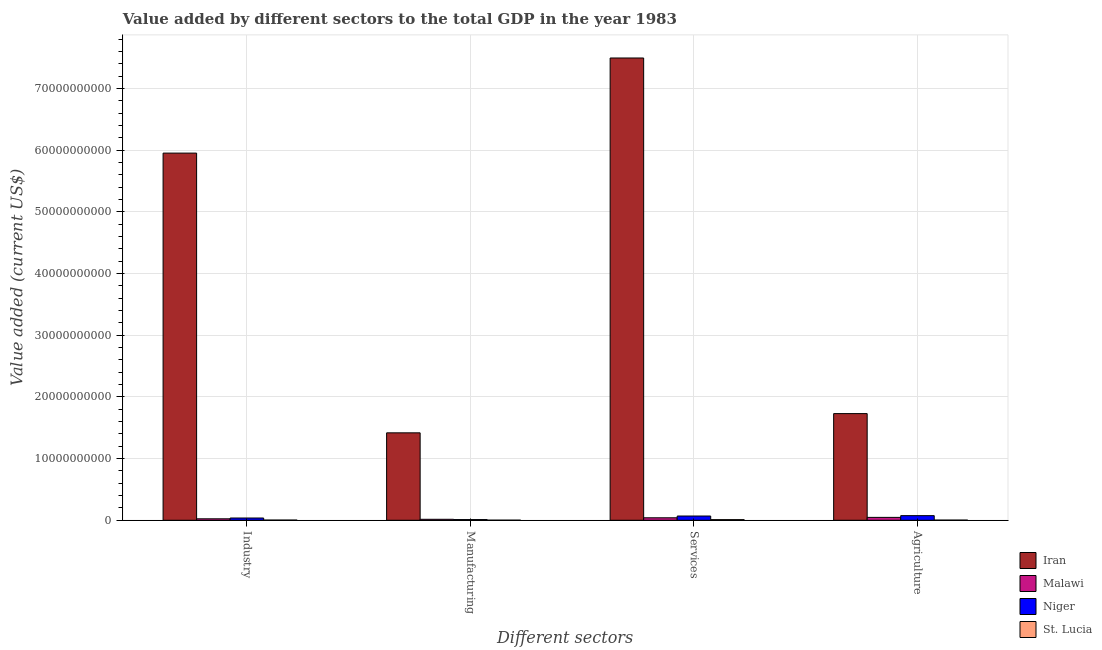How many bars are there on the 4th tick from the left?
Your response must be concise. 4. How many bars are there on the 2nd tick from the right?
Offer a terse response. 4. What is the label of the 4th group of bars from the left?
Your answer should be very brief. Agriculture. What is the value added by industrial sector in Malawi?
Ensure brevity in your answer.  2.37e+08. Across all countries, what is the maximum value added by industrial sector?
Provide a succinct answer. 5.95e+1. Across all countries, what is the minimum value added by industrial sector?
Your answer should be compact. 2.83e+07. In which country was the value added by manufacturing sector maximum?
Keep it short and to the point. Iran. In which country was the value added by services sector minimum?
Offer a terse response. St. Lucia. What is the total value added by industrial sector in the graph?
Your answer should be compact. 6.01e+1. What is the difference between the value added by manufacturing sector in Niger and that in Malawi?
Your answer should be compact. -4.57e+07. What is the difference between the value added by industrial sector in Niger and the value added by services sector in Malawi?
Offer a terse response. -3.54e+07. What is the average value added by agricultural sector per country?
Ensure brevity in your answer.  4.63e+09. What is the difference between the value added by services sector and value added by manufacturing sector in Iran?
Your answer should be compact. 6.08e+1. What is the ratio of the value added by agricultural sector in St. Lucia to that in Malawi?
Give a very brief answer. 0.05. Is the difference between the value added by industrial sector in St. Lucia and Iran greater than the difference between the value added by services sector in St. Lucia and Iran?
Your answer should be compact. Yes. What is the difference between the highest and the second highest value added by manufacturing sector?
Give a very brief answer. 1.40e+1. What is the difference between the highest and the lowest value added by manufacturing sector?
Make the answer very short. 1.42e+1. In how many countries, is the value added by manufacturing sector greater than the average value added by manufacturing sector taken over all countries?
Offer a terse response. 1. Is the sum of the value added by manufacturing sector in Niger and St. Lucia greater than the maximum value added by industrial sector across all countries?
Keep it short and to the point. No. Is it the case that in every country, the sum of the value added by industrial sector and value added by agricultural sector is greater than the sum of value added by services sector and value added by manufacturing sector?
Your answer should be compact. No. What does the 2nd bar from the left in Services represents?
Your answer should be very brief. Malawi. What does the 3rd bar from the right in Services represents?
Offer a terse response. Malawi. Are the values on the major ticks of Y-axis written in scientific E-notation?
Offer a terse response. No. Does the graph contain any zero values?
Your response must be concise. No. Where does the legend appear in the graph?
Offer a very short reply. Bottom right. How many legend labels are there?
Make the answer very short. 4. How are the legend labels stacked?
Provide a succinct answer. Vertical. What is the title of the graph?
Your response must be concise. Value added by different sectors to the total GDP in the year 1983. Does "Micronesia" appear as one of the legend labels in the graph?
Make the answer very short. No. What is the label or title of the X-axis?
Your answer should be very brief. Different sectors. What is the label or title of the Y-axis?
Give a very brief answer. Value added (current US$). What is the Value added (current US$) in Iran in Industry?
Offer a terse response. 5.95e+1. What is the Value added (current US$) in Malawi in Industry?
Keep it short and to the point. 2.37e+08. What is the Value added (current US$) in Niger in Industry?
Your answer should be very brief. 3.65e+08. What is the Value added (current US$) of St. Lucia in Industry?
Offer a terse response. 2.83e+07. What is the Value added (current US$) of Iran in Manufacturing?
Provide a short and direct response. 1.42e+1. What is the Value added (current US$) of Malawi in Manufacturing?
Keep it short and to the point. 1.58e+08. What is the Value added (current US$) of Niger in Manufacturing?
Offer a terse response. 1.13e+08. What is the Value added (current US$) of St. Lucia in Manufacturing?
Offer a terse response. 1.47e+07. What is the Value added (current US$) in Iran in Services?
Your answer should be very brief. 7.49e+1. What is the Value added (current US$) of Malawi in Services?
Provide a succinct answer. 4.00e+08. What is the Value added (current US$) of Niger in Services?
Offer a terse response. 6.88e+08. What is the Value added (current US$) in St. Lucia in Services?
Your response must be concise. 1.03e+08. What is the Value added (current US$) in Iran in Agriculture?
Ensure brevity in your answer.  1.73e+1. What is the Value added (current US$) in Malawi in Agriculture?
Your response must be concise. 4.67e+08. What is the Value added (current US$) in Niger in Agriculture?
Your answer should be very brief. 7.50e+08. What is the Value added (current US$) in St. Lucia in Agriculture?
Offer a very short reply. 2.31e+07. Across all Different sectors, what is the maximum Value added (current US$) in Iran?
Give a very brief answer. 7.49e+1. Across all Different sectors, what is the maximum Value added (current US$) of Malawi?
Your answer should be compact. 4.67e+08. Across all Different sectors, what is the maximum Value added (current US$) in Niger?
Your answer should be compact. 7.50e+08. Across all Different sectors, what is the maximum Value added (current US$) of St. Lucia?
Your answer should be very brief. 1.03e+08. Across all Different sectors, what is the minimum Value added (current US$) in Iran?
Your answer should be very brief. 1.42e+1. Across all Different sectors, what is the minimum Value added (current US$) in Malawi?
Your answer should be very brief. 1.58e+08. Across all Different sectors, what is the minimum Value added (current US$) of Niger?
Offer a very short reply. 1.13e+08. Across all Different sectors, what is the minimum Value added (current US$) in St. Lucia?
Keep it short and to the point. 1.47e+07. What is the total Value added (current US$) in Iran in the graph?
Offer a very short reply. 1.66e+11. What is the total Value added (current US$) in Malawi in the graph?
Provide a short and direct response. 1.26e+09. What is the total Value added (current US$) of Niger in the graph?
Your answer should be very brief. 1.92e+09. What is the total Value added (current US$) of St. Lucia in the graph?
Your answer should be very brief. 1.69e+08. What is the difference between the Value added (current US$) of Iran in Industry and that in Manufacturing?
Your response must be concise. 4.53e+1. What is the difference between the Value added (current US$) in Malawi in Industry and that in Manufacturing?
Provide a short and direct response. 7.86e+07. What is the difference between the Value added (current US$) in Niger in Industry and that in Manufacturing?
Offer a very short reply. 2.52e+08. What is the difference between the Value added (current US$) of St. Lucia in Industry and that in Manufacturing?
Your response must be concise. 1.36e+07. What is the difference between the Value added (current US$) in Iran in Industry and that in Services?
Offer a very short reply. -1.54e+1. What is the difference between the Value added (current US$) in Malawi in Industry and that in Services?
Ensure brevity in your answer.  -1.64e+08. What is the difference between the Value added (current US$) in Niger in Industry and that in Services?
Provide a short and direct response. -3.23e+08. What is the difference between the Value added (current US$) in St. Lucia in Industry and that in Services?
Offer a terse response. -7.47e+07. What is the difference between the Value added (current US$) in Iran in Industry and that in Agriculture?
Provide a short and direct response. 4.22e+1. What is the difference between the Value added (current US$) of Malawi in Industry and that in Agriculture?
Your answer should be compact. -2.30e+08. What is the difference between the Value added (current US$) of Niger in Industry and that in Agriculture?
Your answer should be very brief. -3.85e+08. What is the difference between the Value added (current US$) in St. Lucia in Industry and that in Agriculture?
Offer a terse response. 5.21e+06. What is the difference between the Value added (current US$) in Iran in Manufacturing and that in Services?
Provide a succinct answer. -6.08e+1. What is the difference between the Value added (current US$) of Malawi in Manufacturing and that in Services?
Give a very brief answer. -2.42e+08. What is the difference between the Value added (current US$) in Niger in Manufacturing and that in Services?
Your answer should be very brief. -5.76e+08. What is the difference between the Value added (current US$) of St. Lucia in Manufacturing and that in Services?
Offer a terse response. -8.83e+07. What is the difference between the Value added (current US$) of Iran in Manufacturing and that in Agriculture?
Ensure brevity in your answer.  -3.12e+09. What is the difference between the Value added (current US$) in Malawi in Manufacturing and that in Agriculture?
Provide a succinct answer. -3.09e+08. What is the difference between the Value added (current US$) of Niger in Manufacturing and that in Agriculture?
Your answer should be very brief. -6.37e+08. What is the difference between the Value added (current US$) of St. Lucia in Manufacturing and that in Agriculture?
Offer a terse response. -8.42e+06. What is the difference between the Value added (current US$) in Iran in Services and that in Agriculture?
Provide a succinct answer. 5.76e+1. What is the difference between the Value added (current US$) of Malawi in Services and that in Agriculture?
Keep it short and to the point. -6.67e+07. What is the difference between the Value added (current US$) of Niger in Services and that in Agriculture?
Your answer should be compact. -6.14e+07. What is the difference between the Value added (current US$) of St. Lucia in Services and that in Agriculture?
Offer a very short reply. 7.99e+07. What is the difference between the Value added (current US$) in Iran in Industry and the Value added (current US$) in Malawi in Manufacturing?
Ensure brevity in your answer.  5.94e+1. What is the difference between the Value added (current US$) in Iran in Industry and the Value added (current US$) in Niger in Manufacturing?
Ensure brevity in your answer.  5.94e+1. What is the difference between the Value added (current US$) of Iran in Industry and the Value added (current US$) of St. Lucia in Manufacturing?
Offer a terse response. 5.95e+1. What is the difference between the Value added (current US$) in Malawi in Industry and the Value added (current US$) in Niger in Manufacturing?
Offer a terse response. 1.24e+08. What is the difference between the Value added (current US$) in Malawi in Industry and the Value added (current US$) in St. Lucia in Manufacturing?
Offer a very short reply. 2.22e+08. What is the difference between the Value added (current US$) of Niger in Industry and the Value added (current US$) of St. Lucia in Manufacturing?
Keep it short and to the point. 3.50e+08. What is the difference between the Value added (current US$) in Iran in Industry and the Value added (current US$) in Malawi in Services?
Provide a succinct answer. 5.91e+1. What is the difference between the Value added (current US$) of Iran in Industry and the Value added (current US$) of Niger in Services?
Provide a short and direct response. 5.88e+1. What is the difference between the Value added (current US$) in Iran in Industry and the Value added (current US$) in St. Lucia in Services?
Your response must be concise. 5.94e+1. What is the difference between the Value added (current US$) of Malawi in Industry and the Value added (current US$) of Niger in Services?
Offer a terse response. -4.51e+08. What is the difference between the Value added (current US$) of Malawi in Industry and the Value added (current US$) of St. Lucia in Services?
Give a very brief answer. 1.34e+08. What is the difference between the Value added (current US$) of Niger in Industry and the Value added (current US$) of St. Lucia in Services?
Your response must be concise. 2.62e+08. What is the difference between the Value added (current US$) in Iran in Industry and the Value added (current US$) in Malawi in Agriculture?
Ensure brevity in your answer.  5.90e+1. What is the difference between the Value added (current US$) of Iran in Industry and the Value added (current US$) of Niger in Agriculture?
Offer a very short reply. 5.88e+1. What is the difference between the Value added (current US$) of Iran in Industry and the Value added (current US$) of St. Lucia in Agriculture?
Provide a succinct answer. 5.95e+1. What is the difference between the Value added (current US$) in Malawi in Industry and the Value added (current US$) in Niger in Agriculture?
Give a very brief answer. -5.13e+08. What is the difference between the Value added (current US$) of Malawi in Industry and the Value added (current US$) of St. Lucia in Agriculture?
Give a very brief answer. 2.14e+08. What is the difference between the Value added (current US$) of Niger in Industry and the Value added (current US$) of St. Lucia in Agriculture?
Provide a succinct answer. 3.42e+08. What is the difference between the Value added (current US$) of Iran in Manufacturing and the Value added (current US$) of Malawi in Services?
Offer a very short reply. 1.38e+1. What is the difference between the Value added (current US$) in Iran in Manufacturing and the Value added (current US$) in Niger in Services?
Your answer should be compact. 1.35e+1. What is the difference between the Value added (current US$) of Iran in Manufacturing and the Value added (current US$) of St. Lucia in Services?
Your answer should be very brief. 1.41e+1. What is the difference between the Value added (current US$) of Malawi in Manufacturing and the Value added (current US$) of Niger in Services?
Make the answer very short. -5.30e+08. What is the difference between the Value added (current US$) in Malawi in Manufacturing and the Value added (current US$) in St. Lucia in Services?
Provide a short and direct response. 5.52e+07. What is the difference between the Value added (current US$) in Niger in Manufacturing and the Value added (current US$) in St. Lucia in Services?
Provide a short and direct response. 9.54e+06. What is the difference between the Value added (current US$) of Iran in Manufacturing and the Value added (current US$) of Malawi in Agriculture?
Offer a terse response. 1.37e+1. What is the difference between the Value added (current US$) of Iran in Manufacturing and the Value added (current US$) of Niger in Agriculture?
Ensure brevity in your answer.  1.34e+1. What is the difference between the Value added (current US$) of Iran in Manufacturing and the Value added (current US$) of St. Lucia in Agriculture?
Your answer should be compact. 1.41e+1. What is the difference between the Value added (current US$) in Malawi in Manufacturing and the Value added (current US$) in Niger in Agriculture?
Your answer should be compact. -5.92e+08. What is the difference between the Value added (current US$) of Malawi in Manufacturing and the Value added (current US$) of St. Lucia in Agriculture?
Offer a very short reply. 1.35e+08. What is the difference between the Value added (current US$) in Niger in Manufacturing and the Value added (current US$) in St. Lucia in Agriculture?
Provide a short and direct response. 8.94e+07. What is the difference between the Value added (current US$) of Iran in Services and the Value added (current US$) of Malawi in Agriculture?
Keep it short and to the point. 7.45e+1. What is the difference between the Value added (current US$) of Iran in Services and the Value added (current US$) of Niger in Agriculture?
Keep it short and to the point. 7.42e+1. What is the difference between the Value added (current US$) of Iran in Services and the Value added (current US$) of St. Lucia in Agriculture?
Your response must be concise. 7.49e+1. What is the difference between the Value added (current US$) of Malawi in Services and the Value added (current US$) of Niger in Agriculture?
Make the answer very short. -3.49e+08. What is the difference between the Value added (current US$) in Malawi in Services and the Value added (current US$) in St. Lucia in Agriculture?
Your response must be concise. 3.77e+08. What is the difference between the Value added (current US$) of Niger in Services and the Value added (current US$) of St. Lucia in Agriculture?
Provide a short and direct response. 6.65e+08. What is the average Value added (current US$) in Iran per Different sectors?
Make the answer very short. 4.15e+1. What is the average Value added (current US$) of Malawi per Different sectors?
Offer a terse response. 3.16e+08. What is the average Value added (current US$) in Niger per Different sectors?
Ensure brevity in your answer.  4.79e+08. What is the average Value added (current US$) in St. Lucia per Different sectors?
Keep it short and to the point. 4.23e+07. What is the difference between the Value added (current US$) of Iran and Value added (current US$) of Malawi in Industry?
Give a very brief answer. 5.93e+1. What is the difference between the Value added (current US$) in Iran and Value added (current US$) in Niger in Industry?
Your answer should be compact. 5.91e+1. What is the difference between the Value added (current US$) of Iran and Value added (current US$) of St. Lucia in Industry?
Ensure brevity in your answer.  5.95e+1. What is the difference between the Value added (current US$) of Malawi and Value added (current US$) of Niger in Industry?
Give a very brief answer. -1.28e+08. What is the difference between the Value added (current US$) of Malawi and Value added (current US$) of St. Lucia in Industry?
Make the answer very short. 2.09e+08. What is the difference between the Value added (current US$) in Niger and Value added (current US$) in St. Lucia in Industry?
Your response must be concise. 3.37e+08. What is the difference between the Value added (current US$) in Iran and Value added (current US$) in Malawi in Manufacturing?
Your answer should be very brief. 1.40e+1. What is the difference between the Value added (current US$) in Iran and Value added (current US$) in Niger in Manufacturing?
Your response must be concise. 1.41e+1. What is the difference between the Value added (current US$) of Iran and Value added (current US$) of St. Lucia in Manufacturing?
Your answer should be very brief. 1.42e+1. What is the difference between the Value added (current US$) of Malawi and Value added (current US$) of Niger in Manufacturing?
Your response must be concise. 4.57e+07. What is the difference between the Value added (current US$) in Malawi and Value added (current US$) in St. Lucia in Manufacturing?
Your response must be concise. 1.44e+08. What is the difference between the Value added (current US$) of Niger and Value added (current US$) of St. Lucia in Manufacturing?
Provide a short and direct response. 9.79e+07. What is the difference between the Value added (current US$) of Iran and Value added (current US$) of Malawi in Services?
Make the answer very short. 7.45e+1. What is the difference between the Value added (current US$) of Iran and Value added (current US$) of Niger in Services?
Offer a terse response. 7.42e+1. What is the difference between the Value added (current US$) in Iran and Value added (current US$) in St. Lucia in Services?
Provide a succinct answer. 7.48e+1. What is the difference between the Value added (current US$) in Malawi and Value added (current US$) in Niger in Services?
Your response must be concise. -2.88e+08. What is the difference between the Value added (current US$) of Malawi and Value added (current US$) of St. Lucia in Services?
Provide a succinct answer. 2.97e+08. What is the difference between the Value added (current US$) in Niger and Value added (current US$) in St. Lucia in Services?
Give a very brief answer. 5.85e+08. What is the difference between the Value added (current US$) in Iran and Value added (current US$) in Malawi in Agriculture?
Offer a very short reply. 1.68e+1. What is the difference between the Value added (current US$) of Iran and Value added (current US$) of Niger in Agriculture?
Offer a terse response. 1.65e+1. What is the difference between the Value added (current US$) of Iran and Value added (current US$) of St. Lucia in Agriculture?
Your answer should be compact. 1.73e+1. What is the difference between the Value added (current US$) in Malawi and Value added (current US$) in Niger in Agriculture?
Provide a short and direct response. -2.83e+08. What is the difference between the Value added (current US$) of Malawi and Value added (current US$) of St. Lucia in Agriculture?
Your response must be concise. 4.44e+08. What is the difference between the Value added (current US$) in Niger and Value added (current US$) in St. Lucia in Agriculture?
Provide a short and direct response. 7.27e+08. What is the ratio of the Value added (current US$) of Iran in Industry to that in Manufacturing?
Your response must be concise. 4.2. What is the ratio of the Value added (current US$) of Malawi in Industry to that in Manufacturing?
Provide a short and direct response. 1.5. What is the ratio of the Value added (current US$) of Niger in Industry to that in Manufacturing?
Make the answer very short. 3.24. What is the ratio of the Value added (current US$) in St. Lucia in Industry to that in Manufacturing?
Provide a succinct answer. 1.93. What is the ratio of the Value added (current US$) of Iran in Industry to that in Services?
Make the answer very short. 0.79. What is the ratio of the Value added (current US$) of Malawi in Industry to that in Services?
Offer a very short reply. 0.59. What is the ratio of the Value added (current US$) of Niger in Industry to that in Services?
Offer a terse response. 0.53. What is the ratio of the Value added (current US$) of St. Lucia in Industry to that in Services?
Keep it short and to the point. 0.28. What is the ratio of the Value added (current US$) of Iran in Industry to that in Agriculture?
Ensure brevity in your answer.  3.44. What is the ratio of the Value added (current US$) of Malawi in Industry to that in Agriculture?
Offer a very short reply. 0.51. What is the ratio of the Value added (current US$) in Niger in Industry to that in Agriculture?
Keep it short and to the point. 0.49. What is the ratio of the Value added (current US$) in St. Lucia in Industry to that in Agriculture?
Offer a terse response. 1.23. What is the ratio of the Value added (current US$) of Iran in Manufacturing to that in Services?
Offer a very short reply. 0.19. What is the ratio of the Value added (current US$) of Malawi in Manufacturing to that in Services?
Your response must be concise. 0.4. What is the ratio of the Value added (current US$) in Niger in Manufacturing to that in Services?
Give a very brief answer. 0.16. What is the ratio of the Value added (current US$) of St. Lucia in Manufacturing to that in Services?
Ensure brevity in your answer.  0.14. What is the ratio of the Value added (current US$) of Iran in Manufacturing to that in Agriculture?
Provide a succinct answer. 0.82. What is the ratio of the Value added (current US$) in Malawi in Manufacturing to that in Agriculture?
Make the answer very short. 0.34. What is the ratio of the Value added (current US$) in Niger in Manufacturing to that in Agriculture?
Make the answer very short. 0.15. What is the ratio of the Value added (current US$) in St. Lucia in Manufacturing to that in Agriculture?
Your response must be concise. 0.64. What is the ratio of the Value added (current US$) in Iran in Services to that in Agriculture?
Ensure brevity in your answer.  4.33. What is the ratio of the Value added (current US$) of Malawi in Services to that in Agriculture?
Offer a very short reply. 0.86. What is the ratio of the Value added (current US$) in Niger in Services to that in Agriculture?
Make the answer very short. 0.92. What is the ratio of the Value added (current US$) in St. Lucia in Services to that in Agriculture?
Your answer should be very brief. 4.45. What is the difference between the highest and the second highest Value added (current US$) of Iran?
Your answer should be compact. 1.54e+1. What is the difference between the highest and the second highest Value added (current US$) of Malawi?
Your answer should be very brief. 6.67e+07. What is the difference between the highest and the second highest Value added (current US$) in Niger?
Your response must be concise. 6.14e+07. What is the difference between the highest and the second highest Value added (current US$) in St. Lucia?
Your response must be concise. 7.47e+07. What is the difference between the highest and the lowest Value added (current US$) of Iran?
Offer a terse response. 6.08e+1. What is the difference between the highest and the lowest Value added (current US$) in Malawi?
Offer a very short reply. 3.09e+08. What is the difference between the highest and the lowest Value added (current US$) in Niger?
Your response must be concise. 6.37e+08. What is the difference between the highest and the lowest Value added (current US$) in St. Lucia?
Keep it short and to the point. 8.83e+07. 